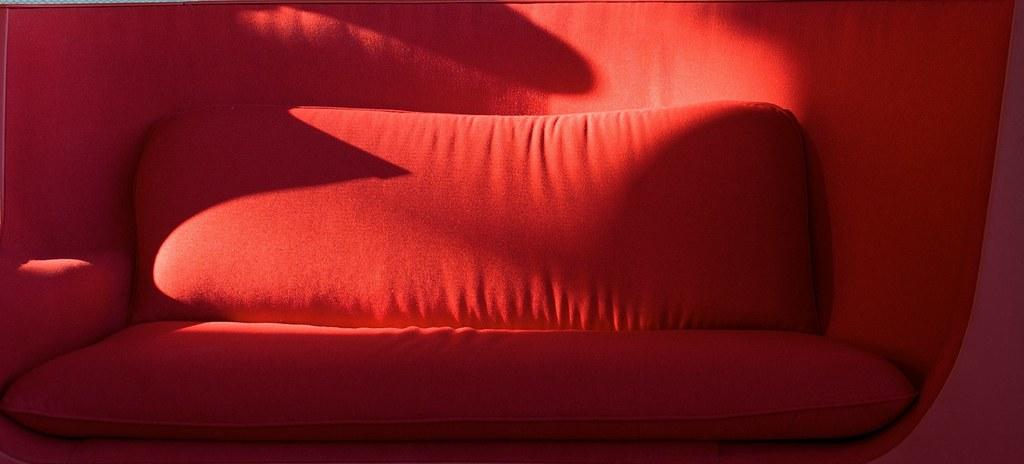What type of furniture is present in the image? There is a couch in the image. Are there any accessories on the couch? Yes, there are two pillows on the couch. What is the name of the person sitting on the couch in the facts? There is no person mentioned in the facts, so we cannot determine their name. 